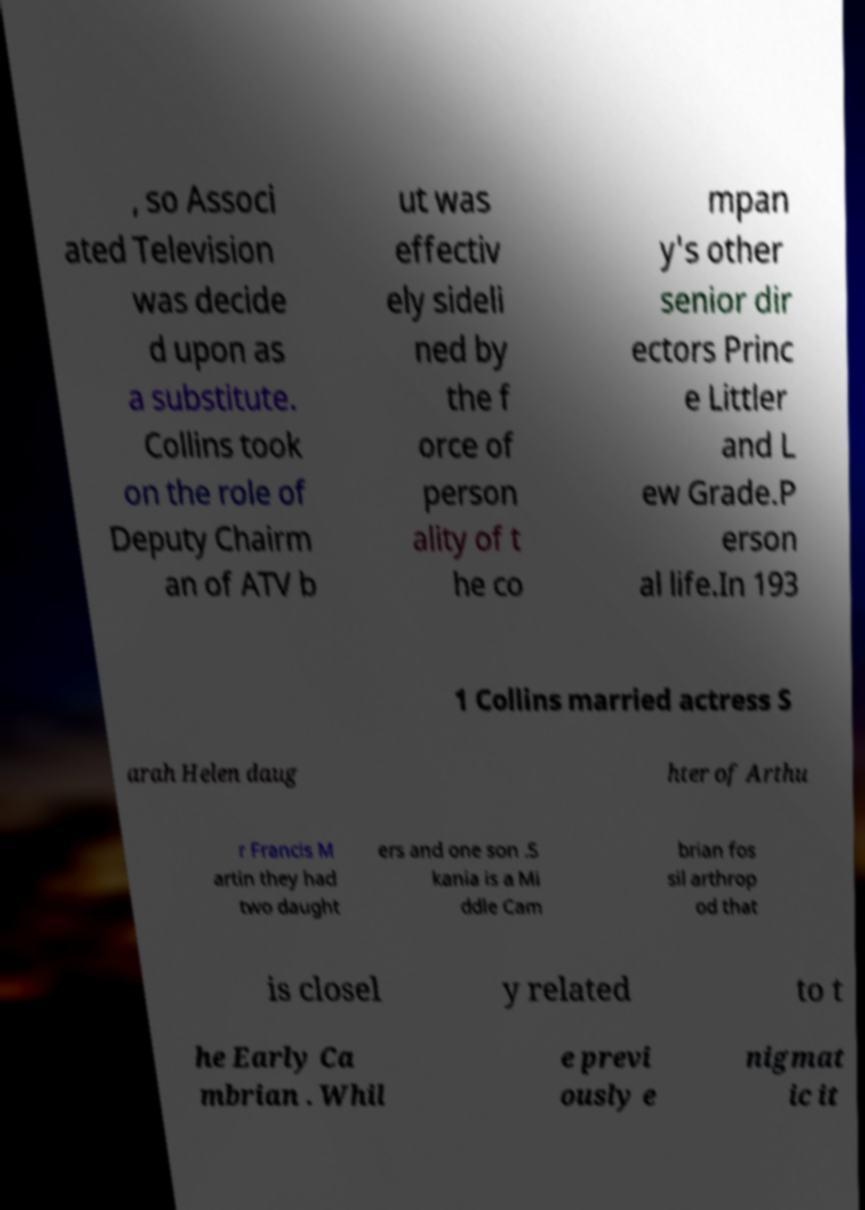Please identify and transcribe the text found in this image. , so Associ ated Television was decide d upon as a substitute. Collins took on the role of Deputy Chairm an of ATV b ut was effectiv ely sideli ned by the f orce of person ality of t he co mpan y's other senior dir ectors Princ e Littler and L ew Grade.P erson al life.In 193 1 Collins married actress S arah Helen daug hter of Arthu r Francis M artin they had two daught ers and one son .S kania is a Mi ddle Cam brian fos sil arthrop od that is closel y related to t he Early Ca mbrian . Whil e previ ously e nigmat ic it 